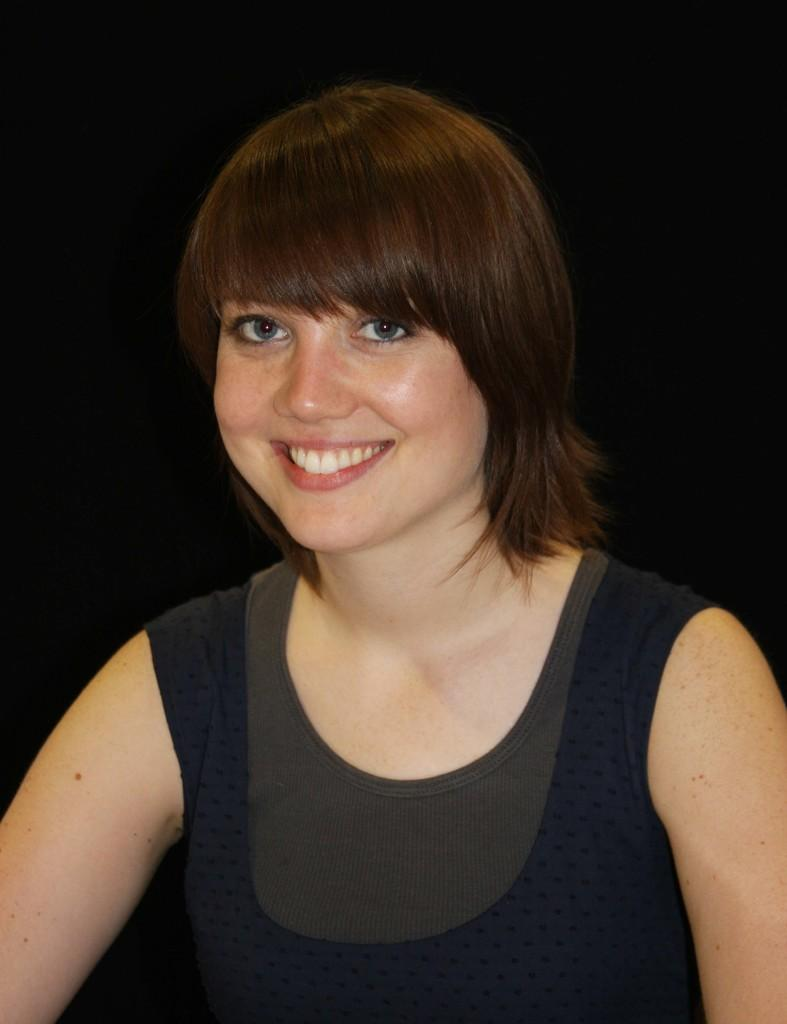Who is present in the image? There is a woman in the image. What is the woman's facial expression? The woman is smiling. What can be observed about the background of the image? The background of the image is dark. How many apples can be seen on the woman's wrist in the image? There are no apples present on the woman's wrist in the image. What type of control does the woman have over the darkness in the background? The woman does not have control over the darkness in the background, as it is a characteristic of the image itself. 